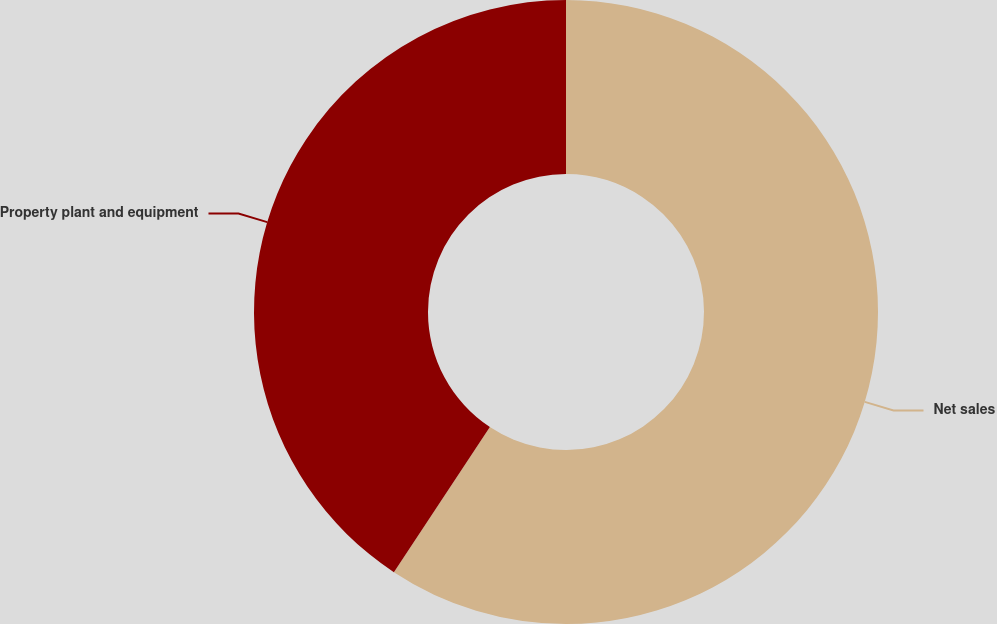Convert chart to OTSL. <chart><loc_0><loc_0><loc_500><loc_500><pie_chart><fcel>Net sales<fcel>Property plant and equipment<nl><fcel>59.3%<fcel>40.7%<nl></chart> 